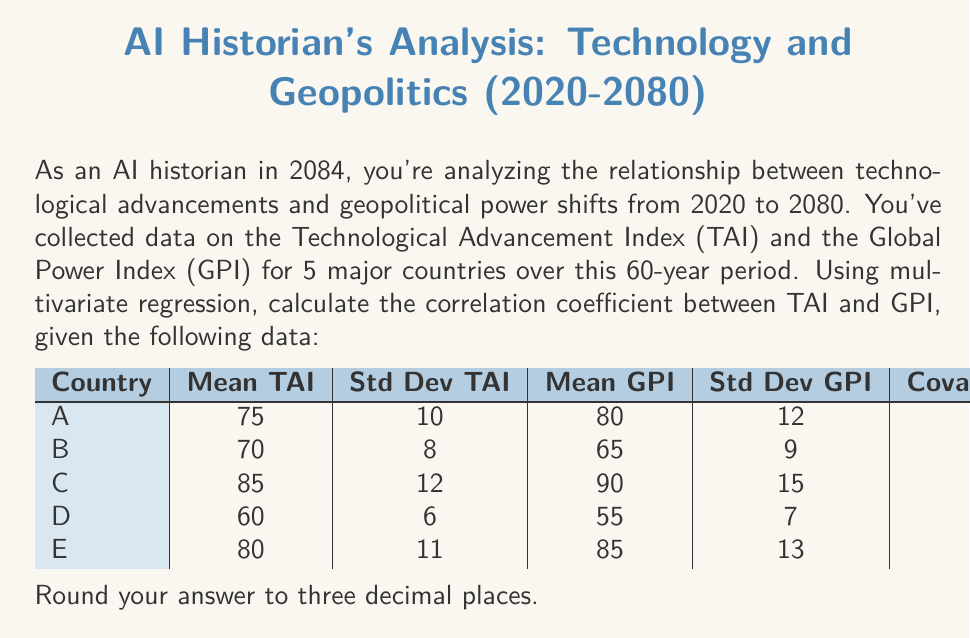Could you help me with this problem? To calculate the correlation coefficient between the Technological Advancement Index (TAI) and the Global Power Index (GPI), we'll use the formula:

$$r = \frac{\text{Cov}(X, Y)}{\sigma_X \sigma_Y}$$

Where:
- $r$ is the correlation coefficient
- $\text{Cov}(X, Y)$ is the covariance between X and Y
- $\sigma_X$ is the standard deviation of X
- $\sigma_Y$ is the standard deviation of Y

In this case, X represents TAI and Y represents GPI.

Step 1: Calculate the average covariance.
Average Covariance = $(95 + 60 + 150 + 35 + 120) / 5 = 92$

Step 2: Calculate the average standard deviations.
Average $\sigma_{TAI} = (10 + 8 + 12 + 6 + 11) / 5 = 9.4$
Average $\sigma_{GPI} = (12 + 9 + 15 + 7 + 13) / 5 = 11.2$

Step 3: Apply the correlation coefficient formula.
$$r = \frac{92}{9.4 \times 11.2} = \frac{92}{105.28} \approx 0.874$$

Step 4: Round to three decimal places.
$r \approx 0.874$
Answer: 0.874 